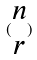Convert formula to latex. <formula><loc_0><loc_0><loc_500><loc_500>( \begin{matrix} n \\ r \end{matrix} )</formula> 